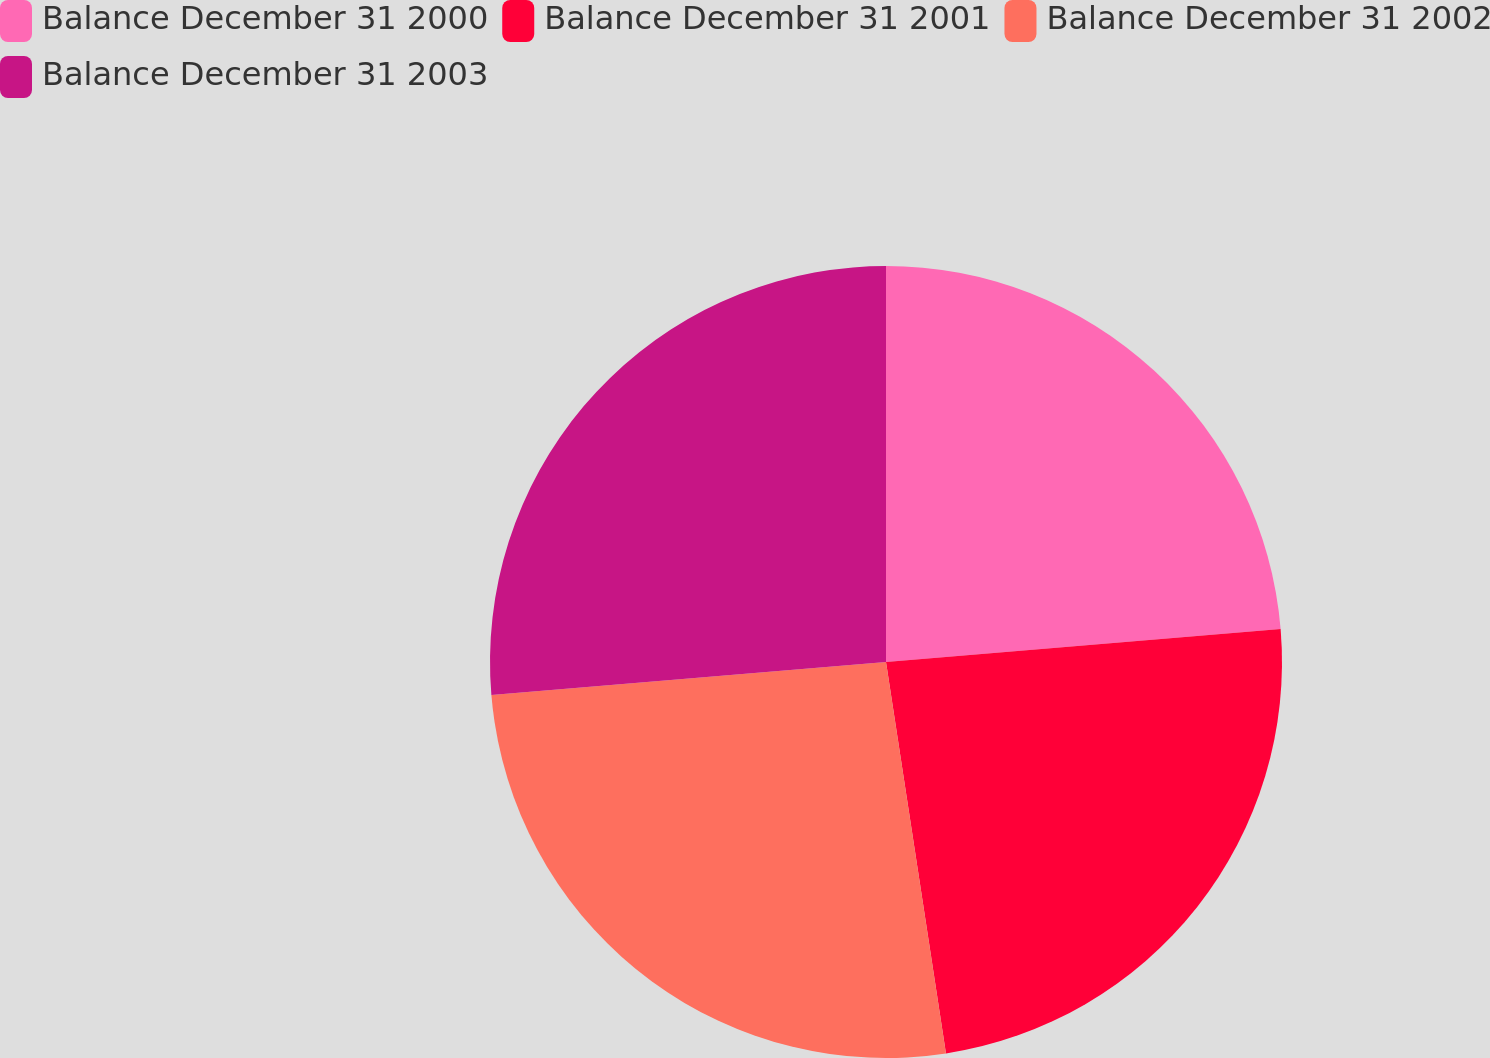Convert chart to OTSL. <chart><loc_0><loc_0><loc_500><loc_500><pie_chart><fcel>Balance December 31 2000<fcel>Balance December 31 2001<fcel>Balance December 31 2002<fcel>Balance December 31 2003<nl><fcel>23.67%<fcel>23.91%<fcel>26.09%<fcel>26.33%<nl></chart> 